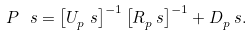<formula> <loc_0><loc_0><loc_500><loc_500>P ^ { \ } s = \left [ U _ { p } ^ { \ } s \right ] ^ { - 1 } \left [ R _ { p } ^ { \ } s \right ] ^ { - 1 } + D _ { p } ^ { \ } s .</formula> 